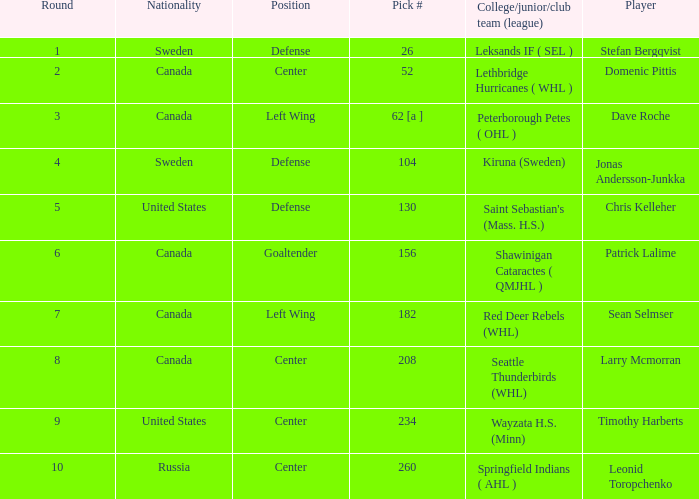What is the pick number for round 2? 52.0. 